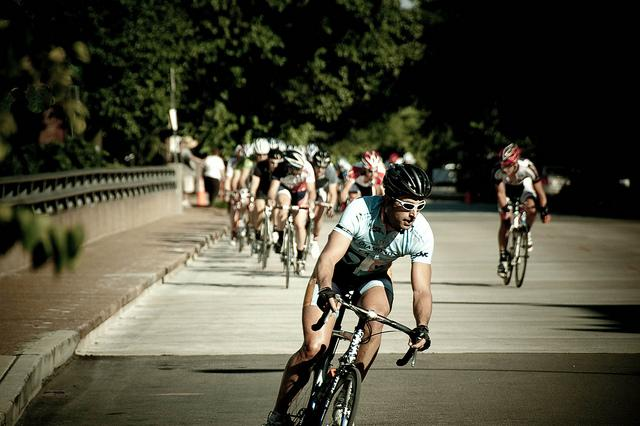What is the most likely reason the street is filled with bicyclists? race 